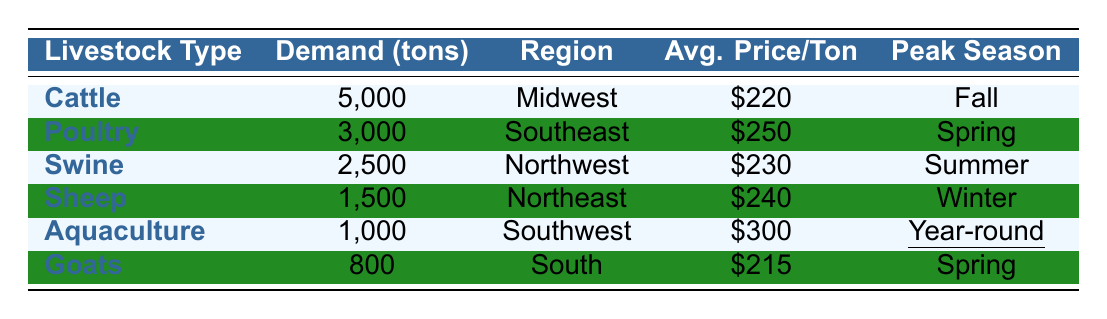What is the total demand for corn feed across all livestock types? To find the total demand, sum the demand quantities: 5000 (Cattle) + 3000 (Poultry) + 2500 (Swine) + 1500 (Sheep) + 1000 (Aquaculture) + 800 (Goats) = 13800 tons.
Answer: 13800 tons Which livestock type has the highest average price per ton? Looking through the average prices in the table, the highest average price per ton is $300 for Aquaculture.
Answer: Aquaculture How much more demand does Cattle have compared to Sheep? The demand for Cattle is 5000 tons and for Sheep is 1500 tons. The difference is 5000 - 1500 = 3500 tons.
Answer: 3500 tons What is the average demand for corn feed per livestock type? There are 6 types of livestock with a total demand of 13800 tons. The average demand is 13800 / 6 = 2300 tons.
Answer: 2300 tons Is the peak season for Aquaculture year-round? The table states that the peak season for Aquaculture is marked as year-round, which qualifies it as a true fact.
Answer: Yes Which region has the highest demand for corn feed? By comparing the demand quantities across the regions, the Midwest with 5000 tons has the highest demand.
Answer: Midwest If you combine the demand for Poultry and Swine, how much total demand does that represent? The demand for Poultry is 3000 tons and for Swine is 2500 tons. The total combined demand is 3000 + 2500 = 5500 tons.
Answer: 5500 tons What is the demand difference between the highest and lowest livestock types? The highest demand is for Cattle at 5000 tons and the lowest is for Goats at 800 tons. The difference is 5000 - 800 = 4200 tons.
Answer: 4200 tons How many livestock types peak in the Spring season? From the table, Poultry and Goats both have their peak season in Spring, so there are 2 types.
Answer: 2 Is the average price for Goats higher than that of Swine? The average price for Goats is $215 and for Swine, it is $230. Since 215 is not higher than 230, this is false.
Answer: No 